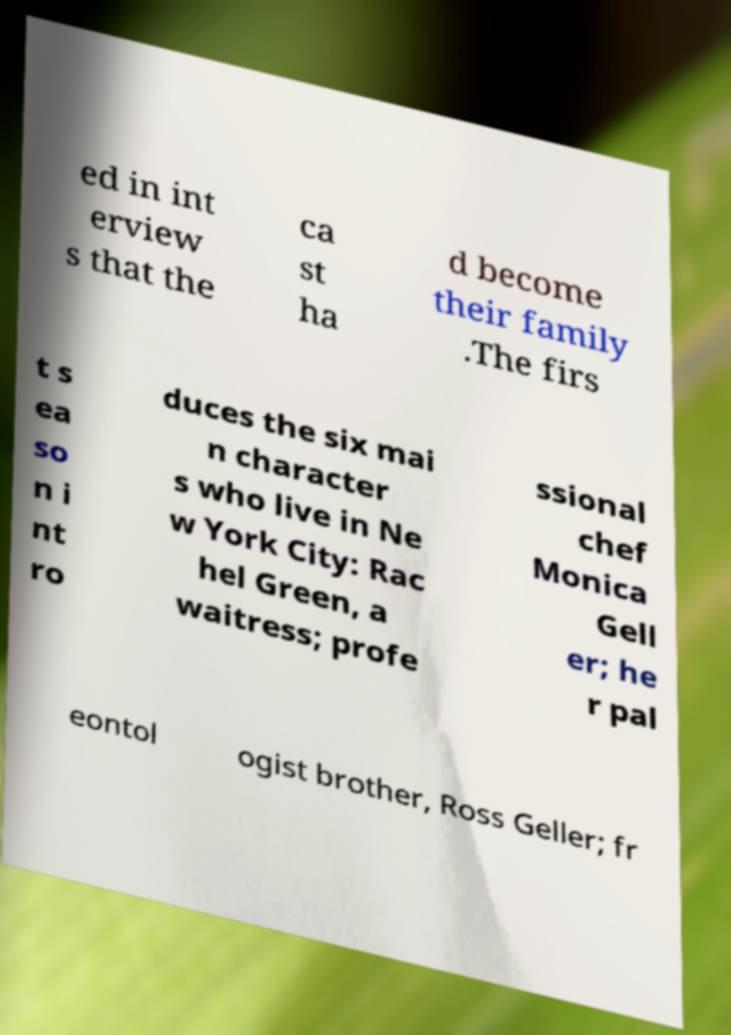Please read and relay the text visible in this image. What does it say? ed in int erview s that the ca st ha d become their family .The firs t s ea so n i nt ro duces the six mai n character s who live in Ne w York City: Rac hel Green, a waitress; profe ssional chef Monica Gell er; he r pal eontol ogist brother, Ross Geller; fr 